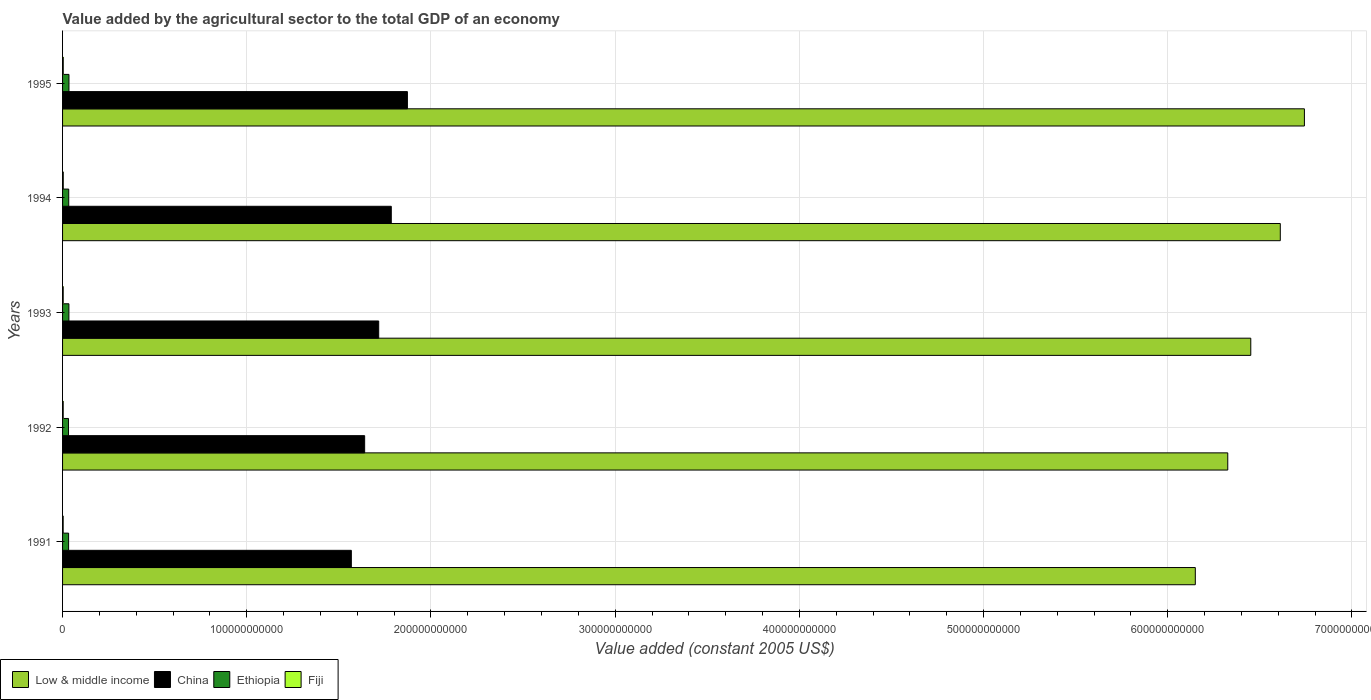How many different coloured bars are there?
Offer a very short reply. 4. How many groups of bars are there?
Offer a very short reply. 5. How many bars are there on the 1st tick from the top?
Give a very brief answer. 4. How many bars are there on the 4th tick from the bottom?
Make the answer very short. 4. In how many cases, is the number of bars for a given year not equal to the number of legend labels?
Provide a short and direct response. 0. What is the value added by the agricultural sector in China in 1991?
Offer a very short reply. 1.57e+11. Across all years, what is the maximum value added by the agricultural sector in China?
Give a very brief answer. 1.87e+11. Across all years, what is the minimum value added by the agricultural sector in Low & middle income?
Your answer should be very brief. 6.15e+11. What is the total value added by the agricultural sector in Ethiopia in the graph?
Keep it short and to the point. 1.68e+1. What is the difference between the value added by the agricultural sector in Fiji in 1993 and that in 1995?
Give a very brief answer. -2.56e+07. What is the difference between the value added by the agricultural sector in Low & middle income in 1994 and the value added by the agricultural sector in Fiji in 1991?
Provide a succinct answer. 6.61e+11. What is the average value added by the agricultural sector in China per year?
Your response must be concise. 1.72e+11. In the year 1994, what is the difference between the value added by the agricultural sector in Low & middle income and value added by the agricultural sector in Fiji?
Keep it short and to the point. 6.61e+11. What is the ratio of the value added by the agricultural sector in Ethiopia in 1992 to that in 1993?
Provide a short and direct response. 0.94. What is the difference between the highest and the second highest value added by the agricultural sector in Ethiopia?
Ensure brevity in your answer.  3.75e+07. What is the difference between the highest and the lowest value added by the agricultural sector in China?
Keep it short and to the point. 3.04e+1. What does the 2nd bar from the top in 1994 represents?
Offer a very short reply. Ethiopia. What does the 3rd bar from the bottom in 1995 represents?
Make the answer very short. Ethiopia. How many bars are there?
Provide a short and direct response. 20. Are all the bars in the graph horizontal?
Offer a terse response. Yes. What is the difference between two consecutive major ticks on the X-axis?
Your response must be concise. 1.00e+11. Are the values on the major ticks of X-axis written in scientific E-notation?
Provide a succinct answer. No. Does the graph contain grids?
Your answer should be compact. Yes. What is the title of the graph?
Keep it short and to the point. Value added by the agricultural sector to the total GDP of an economy. Does "Gabon" appear as one of the legend labels in the graph?
Provide a succinct answer. No. What is the label or title of the X-axis?
Offer a very short reply. Value added (constant 2005 US$). What is the Value added (constant 2005 US$) of Low & middle income in 1991?
Your answer should be very brief. 6.15e+11. What is the Value added (constant 2005 US$) of China in 1991?
Offer a terse response. 1.57e+11. What is the Value added (constant 2005 US$) in Ethiopia in 1991?
Provide a succinct answer. 3.28e+09. What is the Value added (constant 2005 US$) of Fiji in 1991?
Offer a terse response. 3.31e+08. What is the Value added (constant 2005 US$) of Low & middle income in 1992?
Provide a succinct answer. 6.33e+11. What is the Value added (constant 2005 US$) of China in 1992?
Offer a very short reply. 1.64e+11. What is the Value added (constant 2005 US$) in Ethiopia in 1992?
Make the answer very short. 3.23e+09. What is the Value added (constant 2005 US$) in Fiji in 1992?
Offer a very short reply. 3.43e+08. What is the Value added (constant 2005 US$) in Low & middle income in 1993?
Offer a terse response. 6.45e+11. What is the Value added (constant 2005 US$) of China in 1993?
Offer a very short reply. 1.72e+11. What is the Value added (constant 2005 US$) of Ethiopia in 1993?
Your response must be concise. 3.44e+09. What is the Value added (constant 2005 US$) of Fiji in 1993?
Your answer should be compact. 3.46e+08. What is the Value added (constant 2005 US$) of Low & middle income in 1994?
Your answer should be very brief. 6.61e+11. What is the Value added (constant 2005 US$) in China in 1994?
Your answer should be compact. 1.78e+11. What is the Value added (constant 2005 US$) of Ethiopia in 1994?
Ensure brevity in your answer.  3.35e+09. What is the Value added (constant 2005 US$) in Fiji in 1994?
Provide a succinct answer. 3.84e+08. What is the Value added (constant 2005 US$) of Low & middle income in 1995?
Give a very brief answer. 6.74e+11. What is the Value added (constant 2005 US$) of China in 1995?
Provide a succinct answer. 1.87e+11. What is the Value added (constant 2005 US$) of Ethiopia in 1995?
Your response must be concise. 3.48e+09. What is the Value added (constant 2005 US$) of Fiji in 1995?
Offer a terse response. 3.71e+08. Across all years, what is the maximum Value added (constant 2005 US$) in Low & middle income?
Give a very brief answer. 6.74e+11. Across all years, what is the maximum Value added (constant 2005 US$) in China?
Provide a succinct answer. 1.87e+11. Across all years, what is the maximum Value added (constant 2005 US$) of Ethiopia?
Keep it short and to the point. 3.48e+09. Across all years, what is the maximum Value added (constant 2005 US$) of Fiji?
Your response must be concise. 3.84e+08. Across all years, what is the minimum Value added (constant 2005 US$) in Low & middle income?
Give a very brief answer. 6.15e+11. Across all years, what is the minimum Value added (constant 2005 US$) of China?
Your response must be concise. 1.57e+11. Across all years, what is the minimum Value added (constant 2005 US$) of Ethiopia?
Provide a succinct answer. 3.23e+09. Across all years, what is the minimum Value added (constant 2005 US$) in Fiji?
Provide a short and direct response. 3.31e+08. What is the total Value added (constant 2005 US$) of Low & middle income in the graph?
Ensure brevity in your answer.  3.23e+12. What is the total Value added (constant 2005 US$) of China in the graph?
Your answer should be very brief. 8.58e+11. What is the total Value added (constant 2005 US$) in Ethiopia in the graph?
Ensure brevity in your answer.  1.68e+1. What is the total Value added (constant 2005 US$) of Fiji in the graph?
Offer a very short reply. 1.77e+09. What is the difference between the Value added (constant 2005 US$) of Low & middle income in 1991 and that in 1992?
Give a very brief answer. -1.76e+1. What is the difference between the Value added (constant 2005 US$) in China in 1991 and that in 1992?
Make the answer very short. -7.23e+09. What is the difference between the Value added (constant 2005 US$) of Ethiopia in 1991 and that in 1992?
Make the answer very short. 5.13e+07. What is the difference between the Value added (constant 2005 US$) of Fiji in 1991 and that in 1992?
Provide a short and direct response. -1.20e+07. What is the difference between the Value added (constant 2005 US$) in Low & middle income in 1991 and that in 1993?
Your answer should be compact. -3.01e+1. What is the difference between the Value added (constant 2005 US$) of China in 1991 and that in 1993?
Your response must be concise. -1.49e+1. What is the difference between the Value added (constant 2005 US$) in Ethiopia in 1991 and that in 1993?
Make the answer very short. -1.61e+08. What is the difference between the Value added (constant 2005 US$) of Fiji in 1991 and that in 1993?
Ensure brevity in your answer.  -1.46e+07. What is the difference between the Value added (constant 2005 US$) in Low & middle income in 1991 and that in 1994?
Keep it short and to the point. -4.61e+1. What is the difference between the Value added (constant 2005 US$) in China in 1991 and that in 1994?
Ensure brevity in your answer.  -2.17e+1. What is the difference between the Value added (constant 2005 US$) in Ethiopia in 1991 and that in 1994?
Give a very brief answer. -7.25e+07. What is the difference between the Value added (constant 2005 US$) in Fiji in 1991 and that in 1994?
Your answer should be compact. -5.25e+07. What is the difference between the Value added (constant 2005 US$) of Low & middle income in 1991 and that in 1995?
Offer a very short reply. -5.92e+1. What is the difference between the Value added (constant 2005 US$) of China in 1991 and that in 1995?
Your response must be concise. -3.04e+1. What is the difference between the Value added (constant 2005 US$) of Ethiopia in 1991 and that in 1995?
Provide a short and direct response. -1.99e+08. What is the difference between the Value added (constant 2005 US$) in Fiji in 1991 and that in 1995?
Make the answer very short. -4.02e+07. What is the difference between the Value added (constant 2005 US$) in Low & middle income in 1992 and that in 1993?
Your response must be concise. -1.25e+1. What is the difference between the Value added (constant 2005 US$) of China in 1992 and that in 1993?
Ensure brevity in your answer.  -7.63e+09. What is the difference between the Value added (constant 2005 US$) in Ethiopia in 1992 and that in 1993?
Keep it short and to the point. -2.13e+08. What is the difference between the Value added (constant 2005 US$) of Fiji in 1992 and that in 1993?
Your response must be concise. -2.66e+06. What is the difference between the Value added (constant 2005 US$) of Low & middle income in 1992 and that in 1994?
Keep it short and to the point. -2.85e+1. What is the difference between the Value added (constant 2005 US$) in China in 1992 and that in 1994?
Provide a succinct answer. -1.45e+1. What is the difference between the Value added (constant 2005 US$) in Ethiopia in 1992 and that in 1994?
Your answer should be compact. -1.24e+08. What is the difference between the Value added (constant 2005 US$) in Fiji in 1992 and that in 1994?
Provide a short and direct response. -4.05e+07. What is the difference between the Value added (constant 2005 US$) in Low & middle income in 1992 and that in 1995?
Offer a terse response. -4.16e+1. What is the difference between the Value added (constant 2005 US$) of China in 1992 and that in 1995?
Ensure brevity in your answer.  -2.32e+1. What is the difference between the Value added (constant 2005 US$) of Ethiopia in 1992 and that in 1995?
Your answer should be compact. -2.50e+08. What is the difference between the Value added (constant 2005 US$) of Fiji in 1992 and that in 1995?
Provide a succinct answer. -2.82e+07. What is the difference between the Value added (constant 2005 US$) in Low & middle income in 1993 and that in 1994?
Offer a very short reply. -1.60e+1. What is the difference between the Value added (constant 2005 US$) of China in 1993 and that in 1994?
Your answer should be very brief. -6.83e+09. What is the difference between the Value added (constant 2005 US$) in Ethiopia in 1993 and that in 1994?
Your response must be concise. 8.87e+07. What is the difference between the Value added (constant 2005 US$) in Fiji in 1993 and that in 1994?
Keep it short and to the point. -3.79e+07. What is the difference between the Value added (constant 2005 US$) of Low & middle income in 1993 and that in 1995?
Your answer should be compact. -2.91e+1. What is the difference between the Value added (constant 2005 US$) in China in 1993 and that in 1995?
Offer a very short reply. -1.56e+1. What is the difference between the Value added (constant 2005 US$) of Ethiopia in 1993 and that in 1995?
Your answer should be very brief. -3.75e+07. What is the difference between the Value added (constant 2005 US$) in Fiji in 1993 and that in 1995?
Provide a succinct answer. -2.56e+07. What is the difference between the Value added (constant 2005 US$) of Low & middle income in 1994 and that in 1995?
Your response must be concise. -1.31e+1. What is the difference between the Value added (constant 2005 US$) of China in 1994 and that in 1995?
Your response must be concise. -8.75e+09. What is the difference between the Value added (constant 2005 US$) in Ethiopia in 1994 and that in 1995?
Keep it short and to the point. -1.26e+08. What is the difference between the Value added (constant 2005 US$) in Fiji in 1994 and that in 1995?
Give a very brief answer. 1.23e+07. What is the difference between the Value added (constant 2005 US$) in Low & middle income in 1991 and the Value added (constant 2005 US$) in China in 1992?
Offer a very short reply. 4.51e+11. What is the difference between the Value added (constant 2005 US$) of Low & middle income in 1991 and the Value added (constant 2005 US$) of Ethiopia in 1992?
Provide a succinct answer. 6.12e+11. What is the difference between the Value added (constant 2005 US$) in Low & middle income in 1991 and the Value added (constant 2005 US$) in Fiji in 1992?
Ensure brevity in your answer.  6.15e+11. What is the difference between the Value added (constant 2005 US$) of China in 1991 and the Value added (constant 2005 US$) of Ethiopia in 1992?
Keep it short and to the point. 1.54e+11. What is the difference between the Value added (constant 2005 US$) in China in 1991 and the Value added (constant 2005 US$) in Fiji in 1992?
Your answer should be very brief. 1.56e+11. What is the difference between the Value added (constant 2005 US$) in Ethiopia in 1991 and the Value added (constant 2005 US$) in Fiji in 1992?
Your answer should be very brief. 2.94e+09. What is the difference between the Value added (constant 2005 US$) of Low & middle income in 1991 and the Value added (constant 2005 US$) of China in 1993?
Give a very brief answer. 4.43e+11. What is the difference between the Value added (constant 2005 US$) in Low & middle income in 1991 and the Value added (constant 2005 US$) in Ethiopia in 1993?
Give a very brief answer. 6.12e+11. What is the difference between the Value added (constant 2005 US$) in Low & middle income in 1991 and the Value added (constant 2005 US$) in Fiji in 1993?
Provide a short and direct response. 6.15e+11. What is the difference between the Value added (constant 2005 US$) in China in 1991 and the Value added (constant 2005 US$) in Ethiopia in 1993?
Keep it short and to the point. 1.53e+11. What is the difference between the Value added (constant 2005 US$) in China in 1991 and the Value added (constant 2005 US$) in Fiji in 1993?
Offer a very short reply. 1.56e+11. What is the difference between the Value added (constant 2005 US$) of Ethiopia in 1991 and the Value added (constant 2005 US$) of Fiji in 1993?
Your answer should be very brief. 2.93e+09. What is the difference between the Value added (constant 2005 US$) of Low & middle income in 1991 and the Value added (constant 2005 US$) of China in 1994?
Offer a terse response. 4.36e+11. What is the difference between the Value added (constant 2005 US$) of Low & middle income in 1991 and the Value added (constant 2005 US$) of Ethiopia in 1994?
Ensure brevity in your answer.  6.12e+11. What is the difference between the Value added (constant 2005 US$) of Low & middle income in 1991 and the Value added (constant 2005 US$) of Fiji in 1994?
Your answer should be very brief. 6.15e+11. What is the difference between the Value added (constant 2005 US$) in China in 1991 and the Value added (constant 2005 US$) in Ethiopia in 1994?
Your response must be concise. 1.53e+11. What is the difference between the Value added (constant 2005 US$) of China in 1991 and the Value added (constant 2005 US$) of Fiji in 1994?
Make the answer very short. 1.56e+11. What is the difference between the Value added (constant 2005 US$) in Ethiopia in 1991 and the Value added (constant 2005 US$) in Fiji in 1994?
Make the answer very short. 2.89e+09. What is the difference between the Value added (constant 2005 US$) of Low & middle income in 1991 and the Value added (constant 2005 US$) of China in 1995?
Offer a very short reply. 4.28e+11. What is the difference between the Value added (constant 2005 US$) of Low & middle income in 1991 and the Value added (constant 2005 US$) of Ethiopia in 1995?
Make the answer very short. 6.11e+11. What is the difference between the Value added (constant 2005 US$) in Low & middle income in 1991 and the Value added (constant 2005 US$) in Fiji in 1995?
Provide a succinct answer. 6.15e+11. What is the difference between the Value added (constant 2005 US$) of China in 1991 and the Value added (constant 2005 US$) of Ethiopia in 1995?
Ensure brevity in your answer.  1.53e+11. What is the difference between the Value added (constant 2005 US$) of China in 1991 and the Value added (constant 2005 US$) of Fiji in 1995?
Offer a terse response. 1.56e+11. What is the difference between the Value added (constant 2005 US$) in Ethiopia in 1991 and the Value added (constant 2005 US$) in Fiji in 1995?
Offer a terse response. 2.91e+09. What is the difference between the Value added (constant 2005 US$) of Low & middle income in 1992 and the Value added (constant 2005 US$) of China in 1993?
Your answer should be very brief. 4.61e+11. What is the difference between the Value added (constant 2005 US$) in Low & middle income in 1992 and the Value added (constant 2005 US$) in Ethiopia in 1993?
Your answer should be compact. 6.29e+11. What is the difference between the Value added (constant 2005 US$) in Low & middle income in 1992 and the Value added (constant 2005 US$) in Fiji in 1993?
Give a very brief answer. 6.32e+11. What is the difference between the Value added (constant 2005 US$) of China in 1992 and the Value added (constant 2005 US$) of Ethiopia in 1993?
Ensure brevity in your answer.  1.61e+11. What is the difference between the Value added (constant 2005 US$) of China in 1992 and the Value added (constant 2005 US$) of Fiji in 1993?
Ensure brevity in your answer.  1.64e+11. What is the difference between the Value added (constant 2005 US$) of Ethiopia in 1992 and the Value added (constant 2005 US$) of Fiji in 1993?
Your answer should be compact. 2.88e+09. What is the difference between the Value added (constant 2005 US$) in Low & middle income in 1992 and the Value added (constant 2005 US$) in China in 1994?
Your answer should be compact. 4.54e+11. What is the difference between the Value added (constant 2005 US$) of Low & middle income in 1992 and the Value added (constant 2005 US$) of Ethiopia in 1994?
Offer a terse response. 6.29e+11. What is the difference between the Value added (constant 2005 US$) of Low & middle income in 1992 and the Value added (constant 2005 US$) of Fiji in 1994?
Provide a succinct answer. 6.32e+11. What is the difference between the Value added (constant 2005 US$) of China in 1992 and the Value added (constant 2005 US$) of Ethiopia in 1994?
Offer a terse response. 1.61e+11. What is the difference between the Value added (constant 2005 US$) in China in 1992 and the Value added (constant 2005 US$) in Fiji in 1994?
Offer a terse response. 1.64e+11. What is the difference between the Value added (constant 2005 US$) in Ethiopia in 1992 and the Value added (constant 2005 US$) in Fiji in 1994?
Make the answer very short. 2.84e+09. What is the difference between the Value added (constant 2005 US$) of Low & middle income in 1992 and the Value added (constant 2005 US$) of China in 1995?
Your answer should be compact. 4.45e+11. What is the difference between the Value added (constant 2005 US$) of Low & middle income in 1992 and the Value added (constant 2005 US$) of Ethiopia in 1995?
Make the answer very short. 6.29e+11. What is the difference between the Value added (constant 2005 US$) of Low & middle income in 1992 and the Value added (constant 2005 US$) of Fiji in 1995?
Ensure brevity in your answer.  6.32e+11. What is the difference between the Value added (constant 2005 US$) of China in 1992 and the Value added (constant 2005 US$) of Ethiopia in 1995?
Your answer should be very brief. 1.61e+11. What is the difference between the Value added (constant 2005 US$) in China in 1992 and the Value added (constant 2005 US$) in Fiji in 1995?
Provide a succinct answer. 1.64e+11. What is the difference between the Value added (constant 2005 US$) in Ethiopia in 1992 and the Value added (constant 2005 US$) in Fiji in 1995?
Offer a terse response. 2.86e+09. What is the difference between the Value added (constant 2005 US$) in Low & middle income in 1993 and the Value added (constant 2005 US$) in China in 1994?
Offer a terse response. 4.67e+11. What is the difference between the Value added (constant 2005 US$) of Low & middle income in 1993 and the Value added (constant 2005 US$) of Ethiopia in 1994?
Your response must be concise. 6.42e+11. What is the difference between the Value added (constant 2005 US$) of Low & middle income in 1993 and the Value added (constant 2005 US$) of Fiji in 1994?
Make the answer very short. 6.45e+11. What is the difference between the Value added (constant 2005 US$) in China in 1993 and the Value added (constant 2005 US$) in Ethiopia in 1994?
Your answer should be very brief. 1.68e+11. What is the difference between the Value added (constant 2005 US$) of China in 1993 and the Value added (constant 2005 US$) of Fiji in 1994?
Make the answer very short. 1.71e+11. What is the difference between the Value added (constant 2005 US$) in Ethiopia in 1993 and the Value added (constant 2005 US$) in Fiji in 1994?
Keep it short and to the point. 3.06e+09. What is the difference between the Value added (constant 2005 US$) of Low & middle income in 1993 and the Value added (constant 2005 US$) of China in 1995?
Provide a succinct answer. 4.58e+11. What is the difference between the Value added (constant 2005 US$) in Low & middle income in 1993 and the Value added (constant 2005 US$) in Ethiopia in 1995?
Your response must be concise. 6.42e+11. What is the difference between the Value added (constant 2005 US$) in Low & middle income in 1993 and the Value added (constant 2005 US$) in Fiji in 1995?
Your response must be concise. 6.45e+11. What is the difference between the Value added (constant 2005 US$) of China in 1993 and the Value added (constant 2005 US$) of Ethiopia in 1995?
Provide a short and direct response. 1.68e+11. What is the difference between the Value added (constant 2005 US$) of China in 1993 and the Value added (constant 2005 US$) of Fiji in 1995?
Make the answer very short. 1.71e+11. What is the difference between the Value added (constant 2005 US$) in Ethiopia in 1993 and the Value added (constant 2005 US$) in Fiji in 1995?
Offer a terse response. 3.07e+09. What is the difference between the Value added (constant 2005 US$) of Low & middle income in 1994 and the Value added (constant 2005 US$) of China in 1995?
Offer a very short reply. 4.74e+11. What is the difference between the Value added (constant 2005 US$) of Low & middle income in 1994 and the Value added (constant 2005 US$) of Ethiopia in 1995?
Your answer should be very brief. 6.58e+11. What is the difference between the Value added (constant 2005 US$) of Low & middle income in 1994 and the Value added (constant 2005 US$) of Fiji in 1995?
Your answer should be very brief. 6.61e+11. What is the difference between the Value added (constant 2005 US$) of China in 1994 and the Value added (constant 2005 US$) of Ethiopia in 1995?
Ensure brevity in your answer.  1.75e+11. What is the difference between the Value added (constant 2005 US$) of China in 1994 and the Value added (constant 2005 US$) of Fiji in 1995?
Offer a very short reply. 1.78e+11. What is the difference between the Value added (constant 2005 US$) in Ethiopia in 1994 and the Value added (constant 2005 US$) in Fiji in 1995?
Your answer should be compact. 2.98e+09. What is the average Value added (constant 2005 US$) in Low & middle income per year?
Provide a short and direct response. 6.46e+11. What is the average Value added (constant 2005 US$) of China per year?
Give a very brief answer. 1.72e+11. What is the average Value added (constant 2005 US$) in Ethiopia per year?
Keep it short and to the point. 3.35e+09. What is the average Value added (constant 2005 US$) of Fiji per year?
Your answer should be very brief. 3.55e+08. In the year 1991, what is the difference between the Value added (constant 2005 US$) of Low & middle income and Value added (constant 2005 US$) of China?
Provide a short and direct response. 4.58e+11. In the year 1991, what is the difference between the Value added (constant 2005 US$) in Low & middle income and Value added (constant 2005 US$) in Ethiopia?
Give a very brief answer. 6.12e+11. In the year 1991, what is the difference between the Value added (constant 2005 US$) of Low & middle income and Value added (constant 2005 US$) of Fiji?
Your answer should be very brief. 6.15e+11. In the year 1991, what is the difference between the Value added (constant 2005 US$) of China and Value added (constant 2005 US$) of Ethiopia?
Ensure brevity in your answer.  1.53e+11. In the year 1991, what is the difference between the Value added (constant 2005 US$) of China and Value added (constant 2005 US$) of Fiji?
Offer a terse response. 1.56e+11. In the year 1991, what is the difference between the Value added (constant 2005 US$) in Ethiopia and Value added (constant 2005 US$) in Fiji?
Offer a very short reply. 2.95e+09. In the year 1992, what is the difference between the Value added (constant 2005 US$) of Low & middle income and Value added (constant 2005 US$) of China?
Offer a terse response. 4.69e+11. In the year 1992, what is the difference between the Value added (constant 2005 US$) in Low & middle income and Value added (constant 2005 US$) in Ethiopia?
Provide a succinct answer. 6.29e+11. In the year 1992, what is the difference between the Value added (constant 2005 US$) of Low & middle income and Value added (constant 2005 US$) of Fiji?
Offer a terse response. 6.32e+11. In the year 1992, what is the difference between the Value added (constant 2005 US$) of China and Value added (constant 2005 US$) of Ethiopia?
Your response must be concise. 1.61e+11. In the year 1992, what is the difference between the Value added (constant 2005 US$) in China and Value added (constant 2005 US$) in Fiji?
Your response must be concise. 1.64e+11. In the year 1992, what is the difference between the Value added (constant 2005 US$) of Ethiopia and Value added (constant 2005 US$) of Fiji?
Ensure brevity in your answer.  2.88e+09. In the year 1993, what is the difference between the Value added (constant 2005 US$) in Low & middle income and Value added (constant 2005 US$) in China?
Your answer should be very brief. 4.73e+11. In the year 1993, what is the difference between the Value added (constant 2005 US$) in Low & middle income and Value added (constant 2005 US$) in Ethiopia?
Ensure brevity in your answer.  6.42e+11. In the year 1993, what is the difference between the Value added (constant 2005 US$) of Low & middle income and Value added (constant 2005 US$) of Fiji?
Keep it short and to the point. 6.45e+11. In the year 1993, what is the difference between the Value added (constant 2005 US$) of China and Value added (constant 2005 US$) of Ethiopia?
Ensure brevity in your answer.  1.68e+11. In the year 1993, what is the difference between the Value added (constant 2005 US$) in China and Value added (constant 2005 US$) in Fiji?
Your response must be concise. 1.71e+11. In the year 1993, what is the difference between the Value added (constant 2005 US$) in Ethiopia and Value added (constant 2005 US$) in Fiji?
Offer a terse response. 3.09e+09. In the year 1994, what is the difference between the Value added (constant 2005 US$) in Low & middle income and Value added (constant 2005 US$) in China?
Ensure brevity in your answer.  4.83e+11. In the year 1994, what is the difference between the Value added (constant 2005 US$) of Low & middle income and Value added (constant 2005 US$) of Ethiopia?
Offer a very short reply. 6.58e+11. In the year 1994, what is the difference between the Value added (constant 2005 US$) in Low & middle income and Value added (constant 2005 US$) in Fiji?
Offer a terse response. 6.61e+11. In the year 1994, what is the difference between the Value added (constant 2005 US$) of China and Value added (constant 2005 US$) of Ethiopia?
Your response must be concise. 1.75e+11. In the year 1994, what is the difference between the Value added (constant 2005 US$) of China and Value added (constant 2005 US$) of Fiji?
Provide a succinct answer. 1.78e+11. In the year 1994, what is the difference between the Value added (constant 2005 US$) of Ethiopia and Value added (constant 2005 US$) of Fiji?
Provide a succinct answer. 2.97e+09. In the year 1995, what is the difference between the Value added (constant 2005 US$) in Low & middle income and Value added (constant 2005 US$) in China?
Make the answer very short. 4.87e+11. In the year 1995, what is the difference between the Value added (constant 2005 US$) of Low & middle income and Value added (constant 2005 US$) of Ethiopia?
Offer a very short reply. 6.71e+11. In the year 1995, what is the difference between the Value added (constant 2005 US$) in Low & middle income and Value added (constant 2005 US$) in Fiji?
Make the answer very short. 6.74e+11. In the year 1995, what is the difference between the Value added (constant 2005 US$) of China and Value added (constant 2005 US$) of Ethiopia?
Your answer should be very brief. 1.84e+11. In the year 1995, what is the difference between the Value added (constant 2005 US$) in China and Value added (constant 2005 US$) in Fiji?
Keep it short and to the point. 1.87e+11. In the year 1995, what is the difference between the Value added (constant 2005 US$) of Ethiopia and Value added (constant 2005 US$) of Fiji?
Make the answer very short. 3.11e+09. What is the ratio of the Value added (constant 2005 US$) in Low & middle income in 1991 to that in 1992?
Your answer should be compact. 0.97. What is the ratio of the Value added (constant 2005 US$) in China in 1991 to that in 1992?
Your response must be concise. 0.96. What is the ratio of the Value added (constant 2005 US$) in Ethiopia in 1991 to that in 1992?
Ensure brevity in your answer.  1.02. What is the ratio of the Value added (constant 2005 US$) in Fiji in 1991 to that in 1992?
Your answer should be compact. 0.97. What is the ratio of the Value added (constant 2005 US$) of Low & middle income in 1991 to that in 1993?
Give a very brief answer. 0.95. What is the ratio of the Value added (constant 2005 US$) in China in 1991 to that in 1993?
Your answer should be very brief. 0.91. What is the ratio of the Value added (constant 2005 US$) in Ethiopia in 1991 to that in 1993?
Ensure brevity in your answer.  0.95. What is the ratio of the Value added (constant 2005 US$) of Fiji in 1991 to that in 1993?
Ensure brevity in your answer.  0.96. What is the ratio of the Value added (constant 2005 US$) in Low & middle income in 1991 to that in 1994?
Your answer should be compact. 0.93. What is the ratio of the Value added (constant 2005 US$) of China in 1991 to that in 1994?
Make the answer very short. 0.88. What is the ratio of the Value added (constant 2005 US$) of Ethiopia in 1991 to that in 1994?
Offer a terse response. 0.98. What is the ratio of the Value added (constant 2005 US$) in Fiji in 1991 to that in 1994?
Provide a short and direct response. 0.86. What is the ratio of the Value added (constant 2005 US$) in Low & middle income in 1991 to that in 1995?
Your answer should be compact. 0.91. What is the ratio of the Value added (constant 2005 US$) in China in 1991 to that in 1995?
Give a very brief answer. 0.84. What is the ratio of the Value added (constant 2005 US$) of Ethiopia in 1991 to that in 1995?
Make the answer very short. 0.94. What is the ratio of the Value added (constant 2005 US$) of Fiji in 1991 to that in 1995?
Provide a succinct answer. 0.89. What is the ratio of the Value added (constant 2005 US$) in Low & middle income in 1992 to that in 1993?
Provide a succinct answer. 0.98. What is the ratio of the Value added (constant 2005 US$) in China in 1992 to that in 1993?
Provide a short and direct response. 0.96. What is the ratio of the Value added (constant 2005 US$) of Ethiopia in 1992 to that in 1993?
Provide a short and direct response. 0.94. What is the ratio of the Value added (constant 2005 US$) in Low & middle income in 1992 to that in 1994?
Your response must be concise. 0.96. What is the ratio of the Value added (constant 2005 US$) in China in 1992 to that in 1994?
Give a very brief answer. 0.92. What is the ratio of the Value added (constant 2005 US$) in Ethiopia in 1992 to that in 1994?
Make the answer very short. 0.96. What is the ratio of the Value added (constant 2005 US$) in Fiji in 1992 to that in 1994?
Offer a terse response. 0.89. What is the ratio of the Value added (constant 2005 US$) in Low & middle income in 1992 to that in 1995?
Keep it short and to the point. 0.94. What is the ratio of the Value added (constant 2005 US$) of China in 1992 to that in 1995?
Your answer should be very brief. 0.88. What is the ratio of the Value added (constant 2005 US$) in Ethiopia in 1992 to that in 1995?
Your response must be concise. 0.93. What is the ratio of the Value added (constant 2005 US$) of Fiji in 1992 to that in 1995?
Make the answer very short. 0.92. What is the ratio of the Value added (constant 2005 US$) in Low & middle income in 1993 to that in 1994?
Your response must be concise. 0.98. What is the ratio of the Value added (constant 2005 US$) of China in 1993 to that in 1994?
Your response must be concise. 0.96. What is the ratio of the Value added (constant 2005 US$) of Ethiopia in 1993 to that in 1994?
Provide a short and direct response. 1.03. What is the ratio of the Value added (constant 2005 US$) in Fiji in 1993 to that in 1994?
Your answer should be compact. 0.9. What is the ratio of the Value added (constant 2005 US$) in Low & middle income in 1993 to that in 1995?
Offer a very short reply. 0.96. What is the ratio of the Value added (constant 2005 US$) of China in 1993 to that in 1995?
Make the answer very short. 0.92. What is the ratio of the Value added (constant 2005 US$) of Ethiopia in 1993 to that in 1995?
Offer a terse response. 0.99. What is the ratio of the Value added (constant 2005 US$) of Fiji in 1993 to that in 1995?
Your answer should be very brief. 0.93. What is the ratio of the Value added (constant 2005 US$) of Low & middle income in 1994 to that in 1995?
Your answer should be compact. 0.98. What is the ratio of the Value added (constant 2005 US$) in China in 1994 to that in 1995?
Provide a succinct answer. 0.95. What is the ratio of the Value added (constant 2005 US$) of Ethiopia in 1994 to that in 1995?
Your response must be concise. 0.96. What is the ratio of the Value added (constant 2005 US$) of Fiji in 1994 to that in 1995?
Ensure brevity in your answer.  1.03. What is the difference between the highest and the second highest Value added (constant 2005 US$) of Low & middle income?
Ensure brevity in your answer.  1.31e+1. What is the difference between the highest and the second highest Value added (constant 2005 US$) of China?
Provide a succinct answer. 8.75e+09. What is the difference between the highest and the second highest Value added (constant 2005 US$) of Ethiopia?
Make the answer very short. 3.75e+07. What is the difference between the highest and the second highest Value added (constant 2005 US$) of Fiji?
Your answer should be very brief. 1.23e+07. What is the difference between the highest and the lowest Value added (constant 2005 US$) in Low & middle income?
Your answer should be very brief. 5.92e+1. What is the difference between the highest and the lowest Value added (constant 2005 US$) in China?
Your answer should be very brief. 3.04e+1. What is the difference between the highest and the lowest Value added (constant 2005 US$) in Ethiopia?
Make the answer very short. 2.50e+08. What is the difference between the highest and the lowest Value added (constant 2005 US$) in Fiji?
Your answer should be very brief. 5.25e+07. 